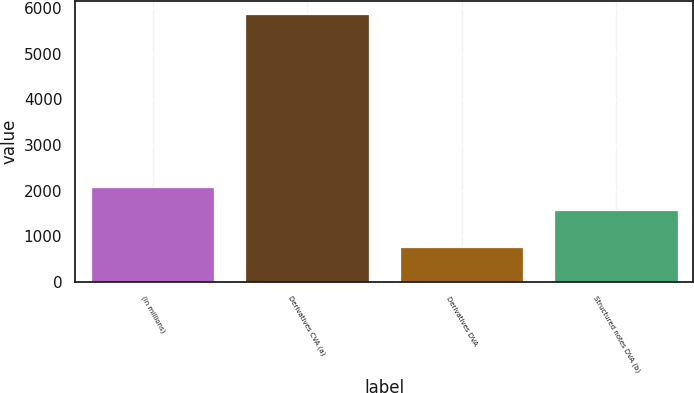Convert chart. <chart><loc_0><loc_0><loc_500><loc_500><bar_chart><fcel>(in millions)<fcel>Derivatives CVA (a)<fcel>Derivatives DVA<fcel>Structured notes DVA (b)<nl><fcel>2083.9<fcel>5869<fcel>760<fcel>1573<nl></chart> 